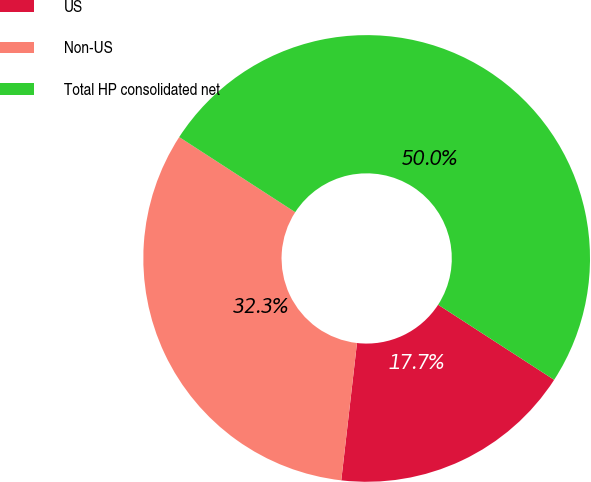Convert chart. <chart><loc_0><loc_0><loc_500><loc_500><pie_chart><fcel>US<fcel>Non-US<fcel>Total HP consolidated net<nl><fcel>17.67%<fcel>32.33%<fcel>50.0%<nl></chart> 